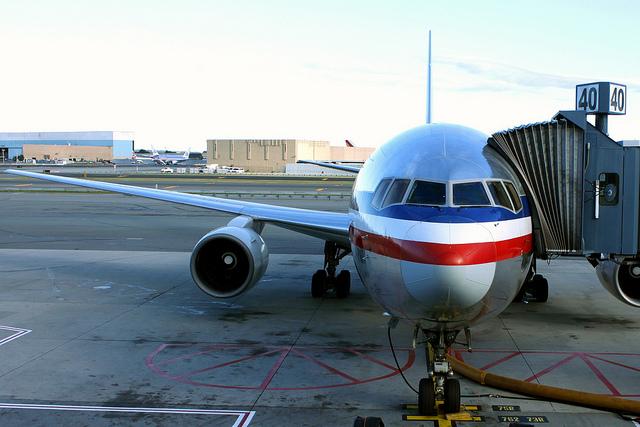From which gate will the passengers be departing?
Short answer required. 40. What number is on the sign?
Give a very brief answer. 40. Is the airplane a single-engine plane?
Answer briefly. No. What color are the stripes on the plane?
Write a very short answer. Red white and blue. How many stores is the parking garage in the back?
Be succinct. 0. 